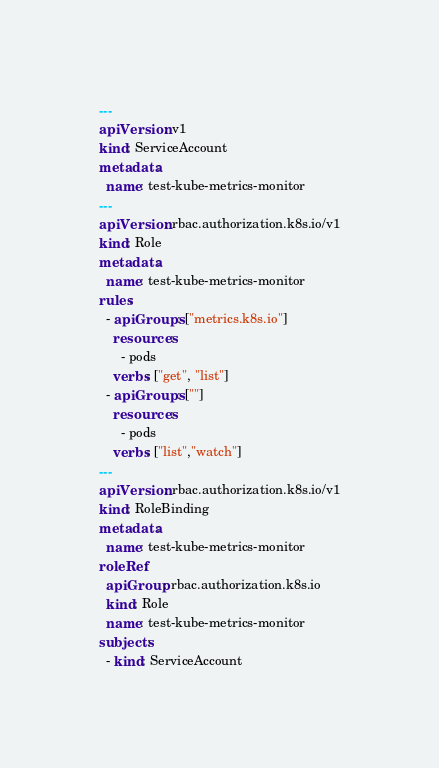<code> <loc_0><loc_0><loc_500><loc_500><_YAML_>---
apiVersion: v1
kind: ServiceAccount
metadata:
  name: test-kube-metrics-monitor
---
apiVersion: rbac.authorization.k8s.io/v1
kind: Role
metadata:
  name: test-kube-metrics-monitor
rules:
  - apiGroups: ["metrics.k8s.io"]
    resources:
      - pods
    verbs: ["get", "list"]
  - apiGroups: [""]
    resources:
      - pods
    verbs: ["list","watch"]
---
apiVersion: rbac.authorization.k8s.io/v1
kind: RoleBinding
metadata:
  name: test-kube-metrics-monitor
roleRef:
  apiGroup: rbac.authorization.k8s.io
  kind: Role
  name: test-kube-metrics-monitor
subjects:
  - kind: ServiceAccount</code> 